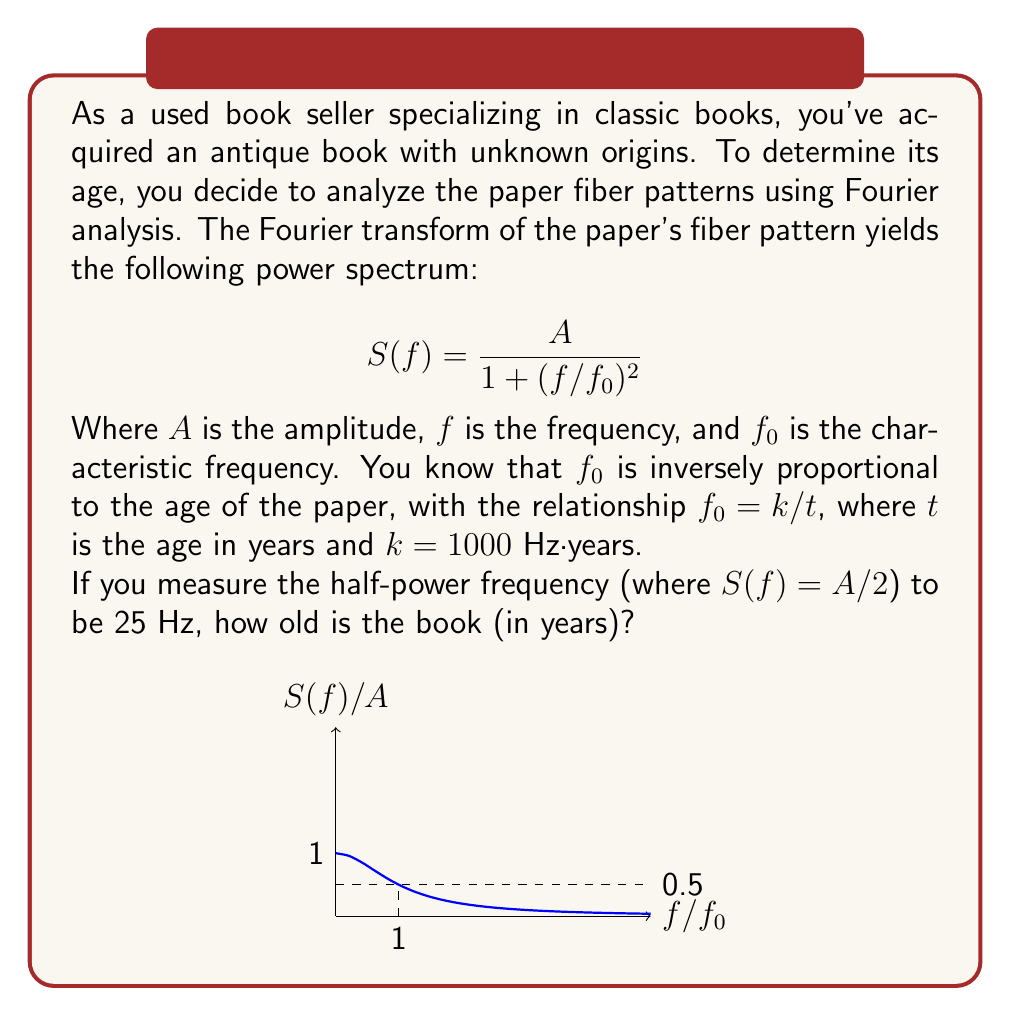Solve this math problem. Let's approach this step-by-step:

1) The half-power frequency is where $S(f) = A/2$. Let's call this frequency $f_{1/2}$. We can find its relationship to $f_0$:

   $$\frac{A}{2} = \frac{A}{1 + (f_{1/2}/f_0)^2}$$

2) Simplify:
   $$2 = 1 + (f_{1/2}/f_0)^2$$
   $$(f_{1/2}/f_0)^2 = 1$$
   $$f_{1/2} = f_0$$

3) We're given that $f_{1/2} = 25$ Hz, so $f_0 = 25$ Hz.

4) We know that $f_0 = k/t$, where $k = 1000$ Hz·years. Let's substitute:

   $$25 = 1000/t$$

5) Solve for $t$:
   $$t = 1000/25 = 40$$

Therefore, the book is 40 years old.
Answer: 40 years 